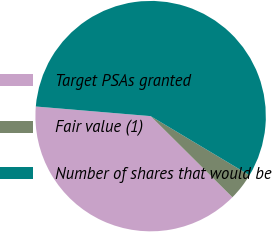Convert chart to OTSL. <chart><loc_0><loc_0><loc_500><loc_500><pie_chart><fcel>Target PSAs granted<fcel>Fair value (1)<fcel>Number of shares that would be<nl><fcel>38.89%<fcel>3.86%<fcel>57.24%<nl></chart> 